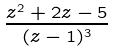Convert formula to latex. <formula><loc_0><loc_0><loc_500><loc_500>\frac { z ^ { 2 } + 2 z - 5 } { ( z - 1 ) ^ { 3 } }</formula> 